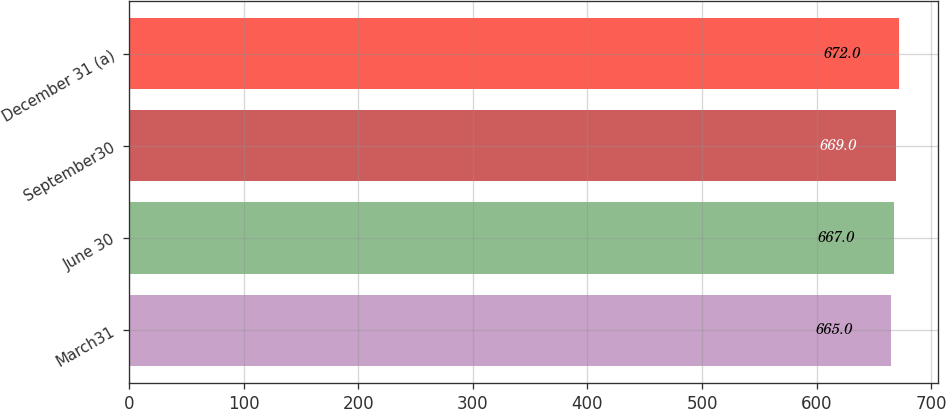Convert chart to OTSL. <chart><loc_0><loc_0><loc_500><loc_500><bar_chart><fcel>March31<fcel>June 30<fcel>September30<fcel>December 31 (a)<nl><fcel>665<fcel>667<fcel>669<fcel>672<nl></chart> 